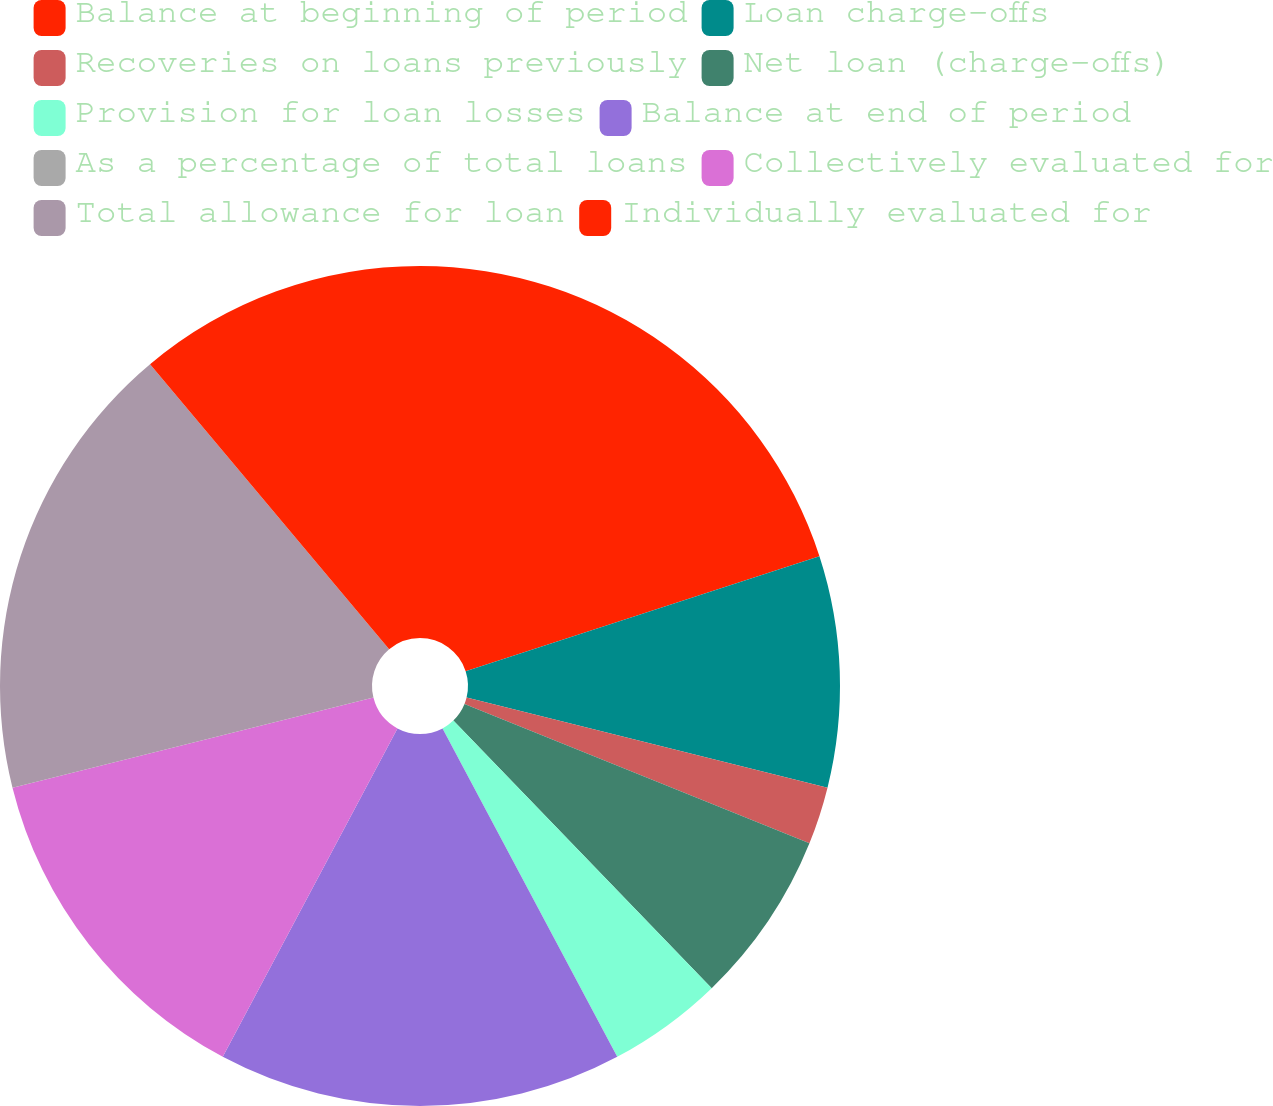Convert chart to OTSL. <chart><loc_0><loc_0><loc_500><loc_500><pie_chart><fcel>Balance at beginning of period<fcel>Loan charge-offs<fcel>Recoveries on loans previously<fcel>Net loan (charge-offs)<fcel>Provision for loan losses<fcel>Balance at end of period<fcel>As a percentage of total loans<fcel>Collectively evaluated for<fcel>Total allowance for loan<fcel>Individually evaluated for<nl><fcel>20.0%<fcel>8.89%<fcel>2.22%<fcel>6.67%<fcel>4.44%<fcel>15.56%<fcel>0.0%<fcel>13.33%<fcel>17.78%<fcel>11.11%<nl></chart> 